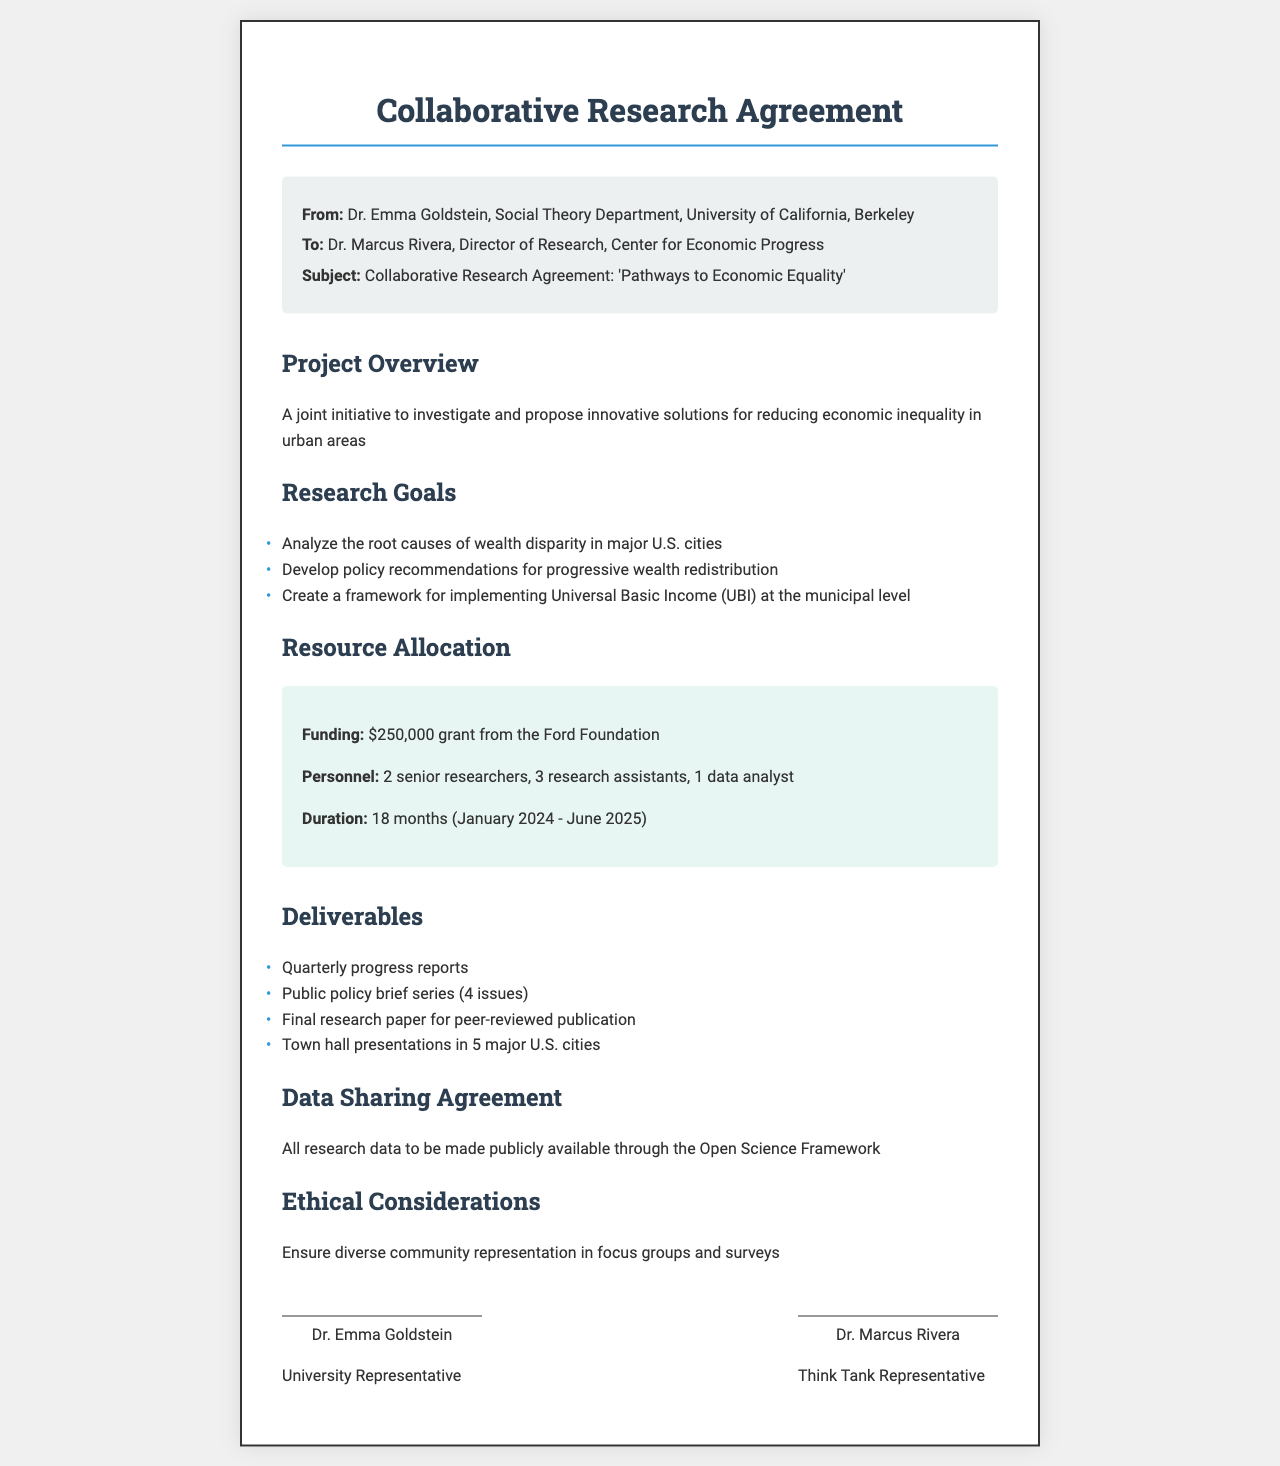What is the subject of the collaboration? The subject is outlined in the header of the document, specifying the focus of the research agreement.
Answer: 'Pathways to Economic Equality' Who is the funding organization for this research? The funding organization is mentioned under the Resource Allocation section of the document.
Answer: Ford Foundation How many senior researchers are allocated to the project? The number of senior researchers is specified in the Resource Allocation section.
Answer: 2 What is the duration of the project? The duration is detailed under Resource Allocation, providing a timeline for the project.
Answer: 18 months What is one of the main research goals? The research goals are summarized in a list, indicating key objectives of the project.
Answer: Analyze the root causes of wealth disparity in major U.S. cities What will be released every three months? This information is found under the Deliverables section, detailing the reporting frequency of progress updates.
Answer: Quarterly progress reports How many town hall presentations are planned? The number of town hall presentations is indicated in the Deliverables section.
Answer: 5 major U.S. cities What is assured in the ethical considerations section? The ethical considerations provide a commitment to diversity, reflecting the responsibility of the researchers.
Answer: Diverse community representation in focus groups and surveys What type of data sharing agreement is mentioned? This term is found in the section discussing data management, highlighting the commitment to transparency.
Answer: Open Science Framework 